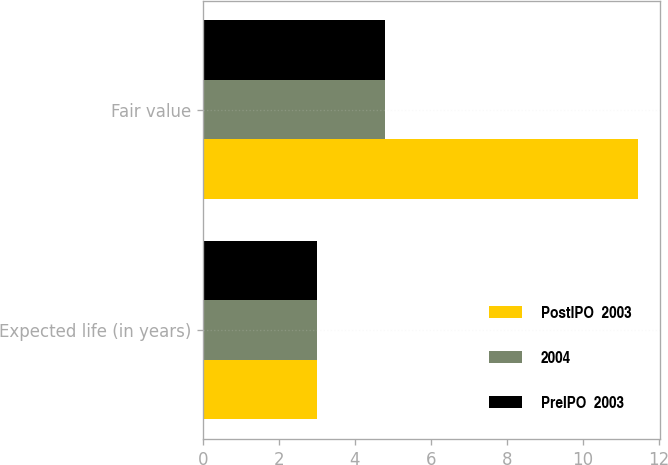<chart> <loc_0><loc_0><loc_500><loc_500><stacked_bar_chart><ecel><fcel>Expected life (in years)<fcel>Fair value<nl><fcel>PostIPO  2003<fcel>3<fcel>11.45<nl><fcel>2004<fcel>3<fcel>4.8<nl><fcel>PreIPO  2003<fcel>3<fcel>4.8<nl></chart> 